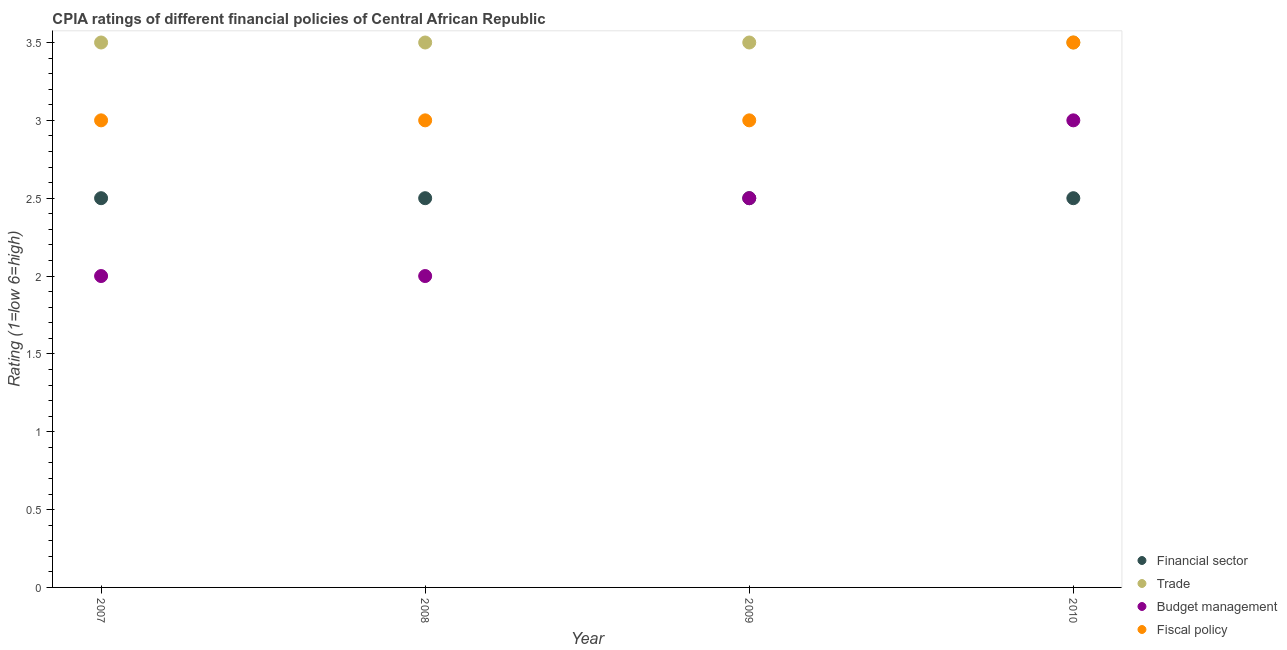How many different coloured dotlines are there?
Make the answer very short. 4. Is the number of dotlines equal to the number of legend labels?
Your answer should be very brief. Yes. What is the cpia rating of financial sector in 2010?
Keep it short and to the point. 2.5. Across all years, what is the minimum cpia rating of fiscal policy?
Keep it short and to the point. 3. In which year was the cpia rating of financial sector maximum?
Ensure brevity in your answer.  2007. In how many years, is the cpia rating of financial sector greater than 0.6?
Keep it short and to the point. 4. What is the difference between the highest and the lowest cpia rating of trade?
Give a very brief answer. 0. In how many years, is the cpia rating of financial sector greater than the average cpia rating of financial sector taken over all years?
Keep it short and to the point. 0. Is it the case that in every year, the sum of the cpia rating of trade and cpia rating of financial sector is greater than the sum of cpia rating of budget management and cpia rating of fiscal policy?
Ensure brevity in your answer.  Yes. Is it the case that in every year, the sum of the cpia rating of financial sector and cpia rating of trade is greater than the cpia rating of budget management?
Ensure brevity in your answer.  Yes. Is the cpia rating of budget management strictly greater than the cpia rating of financial sector over the years?
Offer a very short reply. No. Is the cpia rating of fiscal policy strictly less than the cpia rating of trade over the years?
Offer a terse response. No. How many dotlines are there?
Provide a short and direct response. 4. Are the values on the major ticks of Y-axis written in scientific E-notation?
Give a very brief answer. No. Does the graph contain any zero values?
Offer a very short reply. No. How many legend labels are there?
Your answer should be compact. 4. What is the title of the graph?
Ensure brevity in your answer.  CPIA ratings of different financial policies of Central African Republic. Does "Rule based governance" appear as one of the legend labels in the graph?
Ensure brevity in your answer.  No. What is the label or title of the Y-axis?
Your answer should be compact. Rating (1=low 6=high). What is the Rating (1=low 6=high) of Trade in 2007?
Provide a succinct answer. 3.5. What is the Rating (1=low 6=high) of Budget management in 2007?
Your answer should be compact. 2. What is the Rating (1=low 6=high) in Fiscal policy in 2007?
Offer a very short reply. 3. What is the Rating (1=low 6=high) of Financial sector in 2008?
Your answer should be very brief. 2.5. What is the Rating (1=low 6=high) of Budget management in 2008?
Offer a terse response. 2. What is the Rating (1=low 6=high) in Fiscal policy in 2008?
Keep it short and to the point. 3. What is the Rating (1=low 6=high) of Budget management in 2009?
Keep it short and to the point. 2.5. What is the Rating (1=low 6=high) of Fiscal policy in 2009?
Give a very brief answer. 3. What is the Rating (1=low 6=high) of Financial sector in 2010?
Provide a succinct answer. 2.5. Across all years, what is the maximum Rating (1=low 6=high) in Fiscal policy?
Ensure brevity in your answer.  3.5. Across all years, what is the minimum Rating (1=low 6=high) of Trade?
Your answer should be very brief. 3.5. Across all years, what is the minimum Rating (1=low 6=high) in Budget management?
Your answer should be compact. 2. Across all years, what is the minimum Rating (1=low 6=high) of Fiscal policy?
Make the answer very short. 3. What is the total Rating (1=low 6=high) in Trade in the graph?
Make the answer very short. 14. What is the total Rating (1=low 6=high) of Fiscal policy in the graph?
Make the answer very short. 12.5. What is the difference between the Rating (1=low 6=high) in Budget management in 2007 and that in 2008?
Keep it short and to the point. 0. What is the difference between the Rating (1=low 6=high) in Fiscal policy in 2007 and that in 2008?
Offer a very short reply. 0. What is the difference between the Rating (1=low 6=high) of Financial sector in 2007 and that in 2009?
Give a very brief answer. 0. What is the difference between the Rating (1=low 6=high) in Financial sector in 2007 and that in 2010?
Give a very brief answer. 0. What is the difference between the Rating (1=low 6=high) in Trade in 2007 and that in 2010?
Your answer should be compact. 0. What is the difference between the Rating (1=low 6=high) of Budget management in 2007 and that in 2010?
Provide a short and direct response. -1. What is the difference between the Rating (1=low 6=high) in Fiscal policy in 2007 and that in 2010?
Offer a terse response. -0.5. What is the difference between the Rating (1=low 6=high) of Financial sector in 2008 and that in 2009?
Offer a terse response. 0. What is the difference between the Rating (1=low 6=high) of Fiscal policy in 2008 and that in 2009?
Your response must be concise. 0. What is the difference between the Rating (1=low 6=high) in Financial sector in 2008 and that in 2010?
Your answer should be very brief. 0. What is the difference between the Rating (1=low 6=high) in Trade in 2008 and that in 2010?
Provide a succinct answer. 0. What is the difference between the Rating (1=low 6=high) in Budget management in 2008 and that in 2010?
Offer a terse response. -1. What is the difference between the Rating (1=low 6=high) in Trade in 2009 and that in 2010?
Your answer should be compact. 0. What is the difference between the Rating (1=low 6=high) in Fiscal policy in 2009 and that in 2010?
Ensure brevity in your answer.  -0.5. What is the difference between the Rating (1=low 6=high) of Financial sector in 2007 and the Rating (1=low 6=high) of Budget management in 2008?
Offer a terse response. 0.5. What is the difference between the Rating (1=low 6=high) of Financial sector in 2007 and the Rating (1=low 6=high) of Fiscal policy in 2008?
Your answer should be very brief. -0.5. What is the difference between the Rating (1=low 6=high) in Trade in 2007 and the Rating (1=low 6=high) in Budget management in 2008?
Your answer should be compact. 1.5. What is the difference between the Rating (1=low 6=high) in Trade in 2007 and the Rating (1=low 6=high) in Fiscal policy in 2008?
Provide a short and direct response. 0.5. What is the difference between the Rating (1=low 6=high) of Budget management in 2007 and the Rating (1=low 6=high) of Fiscal policy in 2008?
Make the answer very short. -1. What is the difference between the Rating (1=low 6=high) of Trade in 2007 and the Rating (1=low 6=high) of Budget management in 2009?
Make the answer very short. 1. What is the difference between the Rating (1=low 6=high) in Trade in 2007 and the Rating (1=low 6=high) in Fiscal policy in 2009?
Offer a terse response. 0.5. What is the difference between the Rating (1=low 6=high) of Financial sector in 2007 and the Rating (1=low 6=high) of Budget management in 2010?
Your answer should be very brief. -0.5. What is the difference between the Rating (1=low 6=high) of Financial sector in 2007 and the Rating (1=low 6=high) of Fiscal policy in 2010?
Make the answer very short. -1. What is the difference between the Rating (1=low 6=high) in Trade in 2007 and the Rating (1=low 6=high) in Fiscal policy in 2010?
Provide a short and direct response. 0. What is the difference between the Rating (1=low 6=high) of Budget management in 2007 and the Rating (1=low 6=high) of Fiscal policy in 2010?
Offer a very short reply. -1.5. What is the difference between the Rating (1=low 6=high) of Financial sector in 2008 and the Rating (1=low 6=high) of Budget management in 2009?
Offer a very short reply. 0. What is the difference between the Rating (1=low 6=high) in Financial sector in 2008 and the Rating (1=low 6=high) in Fiscal policy in 2009?
Your answer should be very brief. -0.5. What is the difference between the Rating (1=low 6=high) in Trade in 2008 and the Rating (1=low 6=high) in Budget management in 2009?
Your answer should be compact. 1. What is the difference between the Rating (1=low 6=high) in Financial sector in 2008 and the Rating (1=low 6=high) in Fiscal policy in 2010?
Offer a terse response. -1. What is the difference between the Rating (1=low 6=high) in Trade in 2008 and the Rating (1=low 6=high) in Fiscal policy in 2010?
Offer a very short reply. 0. What is the difference between the Rating (1=low 6=high) of Budget management in 2008 and the Rating (1=low 6=high) of Fiscal policy in 2010?
Your response must be concise. -1.5. What is the difference between the Rating (1=low 6=high) of Financial sector in 2009 and the Rating (1=low 6=high) of Trade in 2010?
Keep it short and to the point. -1. What is the difference between the Rating (1=low 6=high) in Trade in 2009 and the Rating (1=low 6=high) in Budget management in 2010?
Your answer should be very brief. 0.5. What is the average Rating (1=low 6=high) of Financial sector per year?
Your answer should be compact. 2.5. What is the average Rating (1=low 6=high) of Budget management per year?
Keep it short and to the point. 2.38. What is the average Rating (1=low 6=high) in Fiscal policy per year?
Offer a terse response. 3.12. In the year 2007, what is the difference between the Rating (1=low 6=high) of Financial sector and Rating (1=low 6=high) of Trade?
Keep it short and to the point. -1. In the year 2007, what is the difference between the Rating (1=low 6=high) in Financial sector and Rating (1=low 6=high) in Budget management?
Give a very brief answer. 0.5. In the year 2007, what is the difference between the Rating (1=low 6=high) in Financial sector and Rating (1=low 6=high) in Fiscal policy?
Provide a short and direct response. -0.5. In the year 2007, what is the difference between the Rating (1=low 6=high) in Trade and Rating (1=low 6=high) in Fiscal policy?
Provide a short and direct response. 0.5. In the year 2007, what is the difference between the Rating (1=low 6=high) of Budget management and Rating (1=low 6=high) of Fiscal policy?
Your response must be concise. -1. In the year 2008, what is the difference between the Rating (1=low 6=high) of Financial sector and Rating (1=low 6=high) of Budget management?
Give a very brief answer. 0.5. In the year 2008, what is the difference between the Rating (1=low 6=high) of Financial sector and Rating (1=low 6=high) of Fiscal policy?
Your response must be concise. -0.5. In the year 2008, what is the difference between the Rating (1=low 6=high) of Trade and Rating (1=low 6=high) of Budget management?
Keep it short and to the point. 1.5. In the year 2008, what is the difference between the Rating (1=low 6=high) in Budget management and Rating (1=low 6=high) in Fiscal policy?
Give a very brief answer. -1. In the year 2009, what is the difference between the Rating (1=low 6=high) in Trade and Rating (1=low 6=high) in Budget management?
Keep it short and to the point. 1. In the year 2010, what is the difference between the Rating (1=low 6=high) of Financial sector and Rating (1=low 6=high) of Budget management?
Ensure brevity in your answer.  -0.5. In the year 2010, what is the difference between the Rating (1=low 6=high) in Trade and Rating (1=low 6=high) in Budget management?
Offer a very short reply. 0.5. In the year 2010, what is the difference between the Rating (1=low 6=high) in Trade and Rating (1=low 6=high) in Fiscal policy?
Your answer should be compact. 0. What is the ratio of the Rating (1=low 6=high) of Financial sector in 2007 to that in 2008?
Offer a very short reply. 1. What is the ratio of the Rating (1=low 6=high) of Trade in 2007 to that in 2008?
Your response must be concise. 1. What is the ratio of the Rating (1=low 6=high) of Budget management in 2007 to that in 2008?
Make the answer very short. 1. What is the ratio of the Rating (1=low 6=high) of Budget management in 2007 to that in 2009?
Your response must be concise. 0.8. What is the ratio of the Rating (1=low 6=high) of Fiscal policy in 2007 to that in 2010?
Your answer should be very brief. 0.86. What is the ratio of the Rating (1=low 6=high) of Financial sector in 2008 to that in 2009?
Provide a short and direct response. 1. What is the ratio of the Rating (1=low 6=high) of Trade in 2008 to that in 2009?
Provide a short and direct response. 1. What is the ratio of the Rating (1=low 6=high) in Budget management in 2008 to that in 2009?
Provide a short and direct response. 0.8. What is the ratio of the Rating (1=low 6=high) in Fiscal policy in 2008 to that in 2009?
Give a very brief answer. 1. What is the ratio of the Rating (1=low 6=high) in Trade in 2008 to that in 2010?
Offer a terse response. 1. What is the ratio of the Rating (1=low 6=high) of Budget management in 2008 to that in 2010?
Make the answer very short. 0.67. What is the ratio of the Rating (1=low 6=high) in Financial sector in 2009 to that in 2010?
Offer a very short reply. 1. What is the ratio of the Rating (1=low 6=high) in Trade in 2009 to that in 2010?
Ensure brevity in your answer.  1. What is the difference between the highest and the second highest Rating (1=low 6=high) in Trade?
Ensure brevity in your answer.  0. What is the difference between the highest and the second highest Rating (1=low 6=high) of Budget management?
Your answer should be very brief. 0.5. What is the difference between the highest and the lowest Rating (1=low 6=high) of Financial sector?
Ensure brevity in your answer.  0. What is the difference between the highest and the lowest Rating (1=low 6=high) in Trade?
Your answer should be very brief. 0. What is the difference between the highest and the lowest Rating (1=low 6=high) in Budget management?
Keep it short and to the point. 1. 